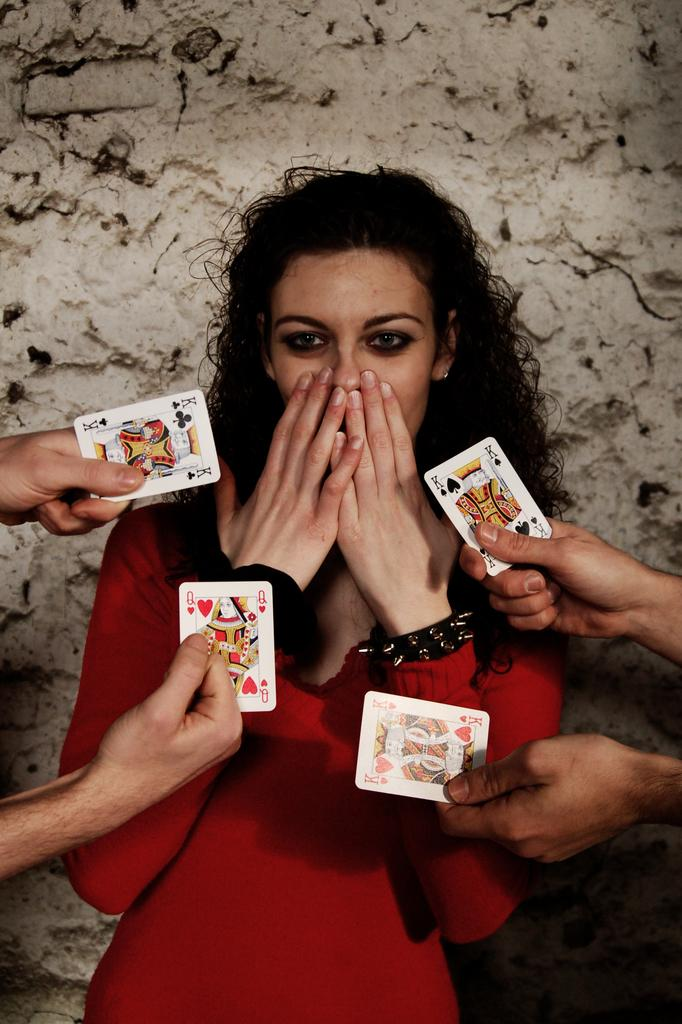Who is the main subject in the image? There is a woman in the image. What is the woman wearing? The woman is wearing a red dress. What is the woman doing with her hands? The woman is covering her mouth with both hands. What else can be seen in the image besides the woman? There are two hands holding playing cards on either side of the woman. What flavor of frog is sitting on the woman's shoulder in the image? There is no frog present in the image, and therefore no flavor can be determined. 